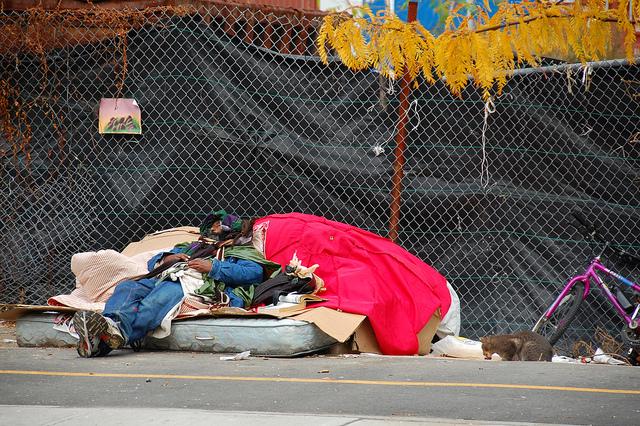What is the man doing?
Concise answer only. Sleeping. Does this man appear to have a home?
Keep it brief. No. Is this an old mattress?
Concise answer only. Yes. 